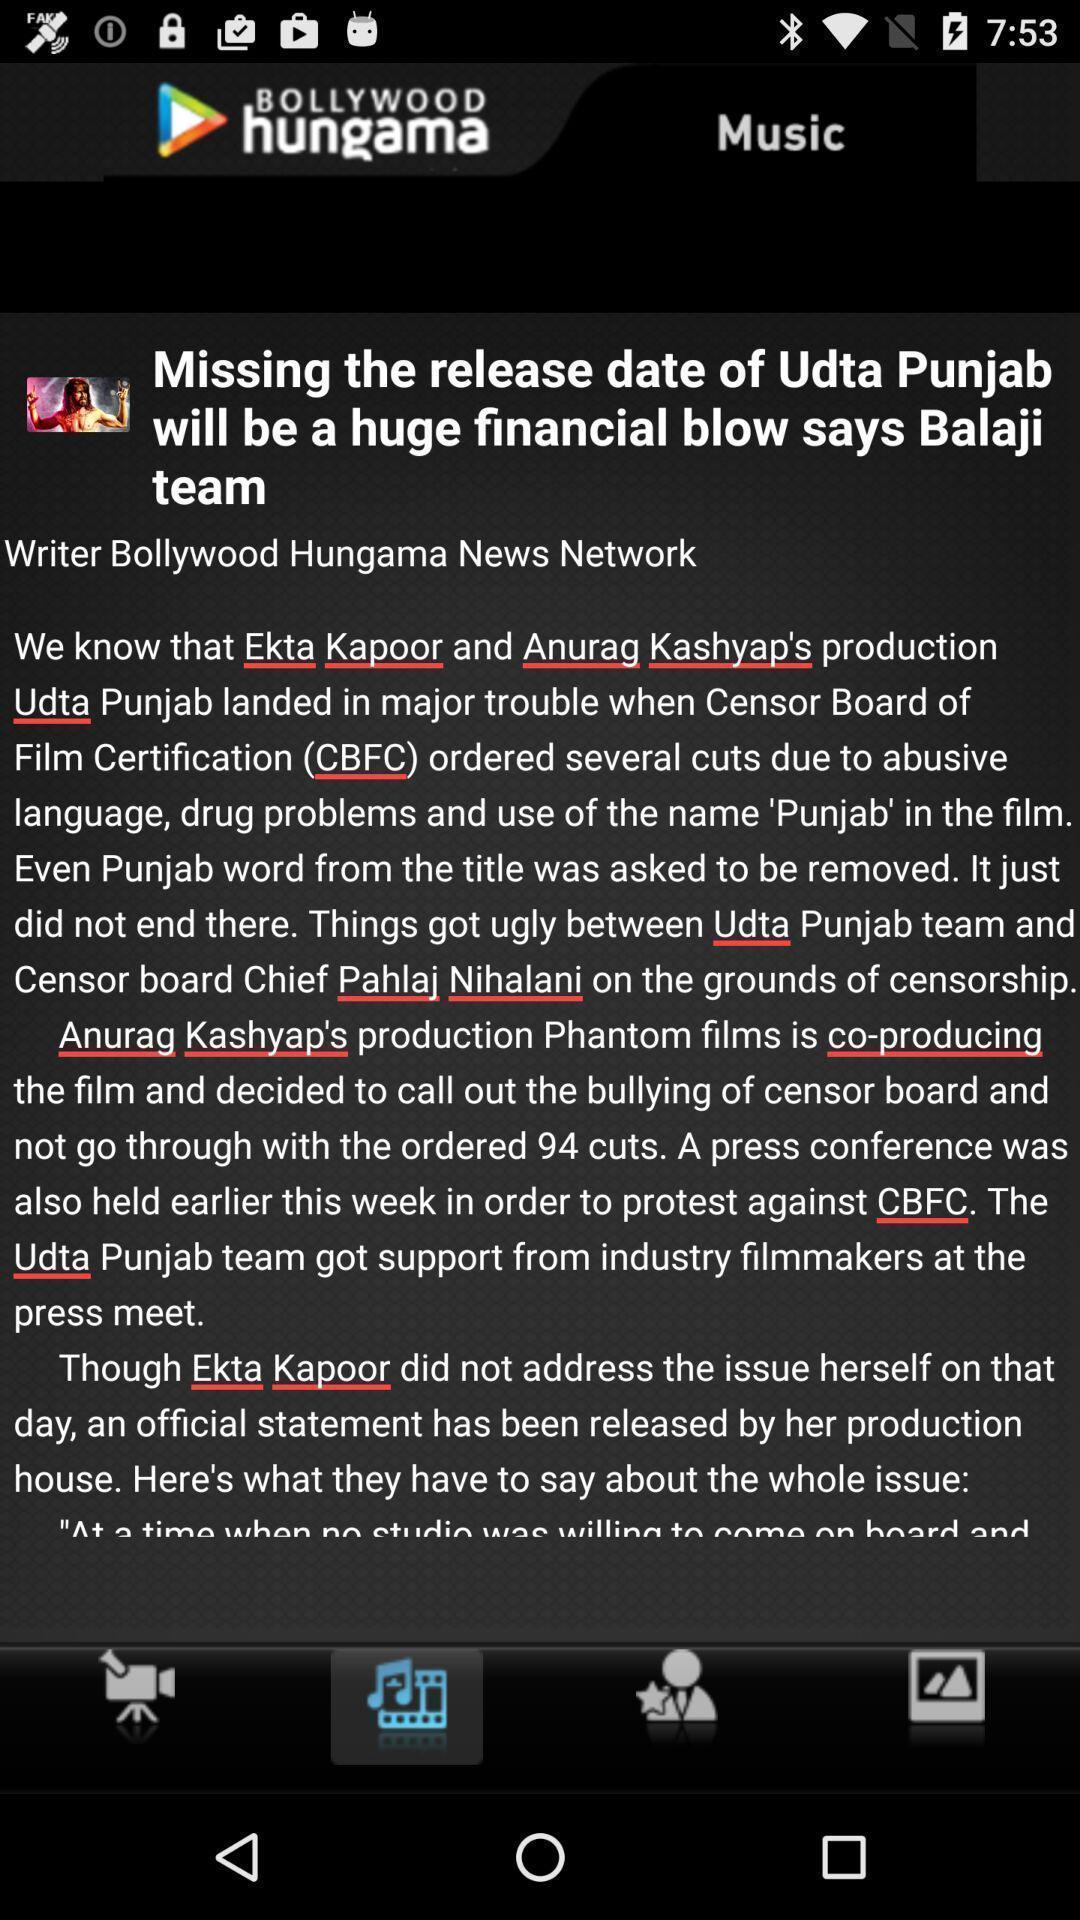Tell me about the visual elements in this screen capture. Page showing information. 